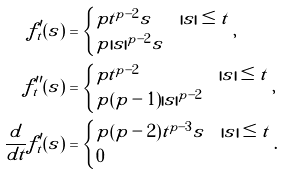Convert formula to latex. <formula><loc_0><loc_0><loc_500><loc_500>f _ { t } ^ { \prime } ( s ) & = \begin{cases} p t ^ { p - 2 } s & | s | \leq t \\ p | s | ^ { p - 2 } s & \end{cases} , \\ f _ { t } ^ { \prime \prime } ( s ) & = \begin{cases} p t ^ { p - 2 } & | s | \leq t \\ p ( p - 1 ) | s | ^ { p - 2 } & \end{cases} , \\ \frac { d } { d t } f _ { t } ^ { \prime } ( s ) & = \begin{cases} p ( p - 2 ) t ^ { p - 3 } s & | s | \leq t \\ 0 & \end{cases} .</formula> 